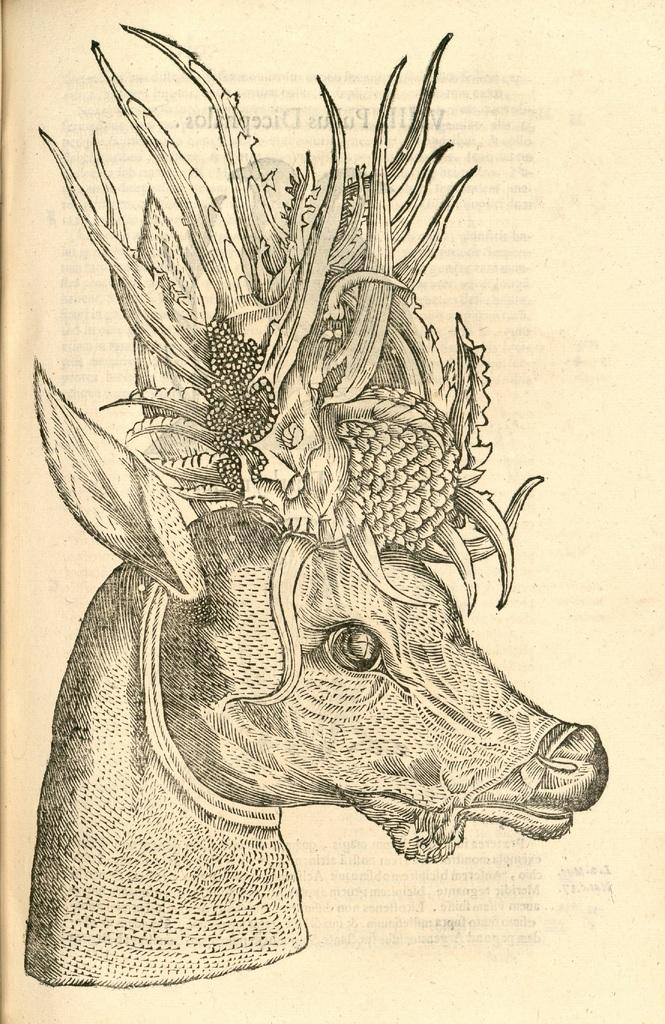What is depicted in the image? There is a sketch of an animal in the image. What is the medium of the sketch? The sketch is on a paper. What color is used for the sketch? The sketch is in black color. How many men are drinking wine in the image? There are no men or wine present in the image; it only features a sketch of an animal on a paper in black color. 